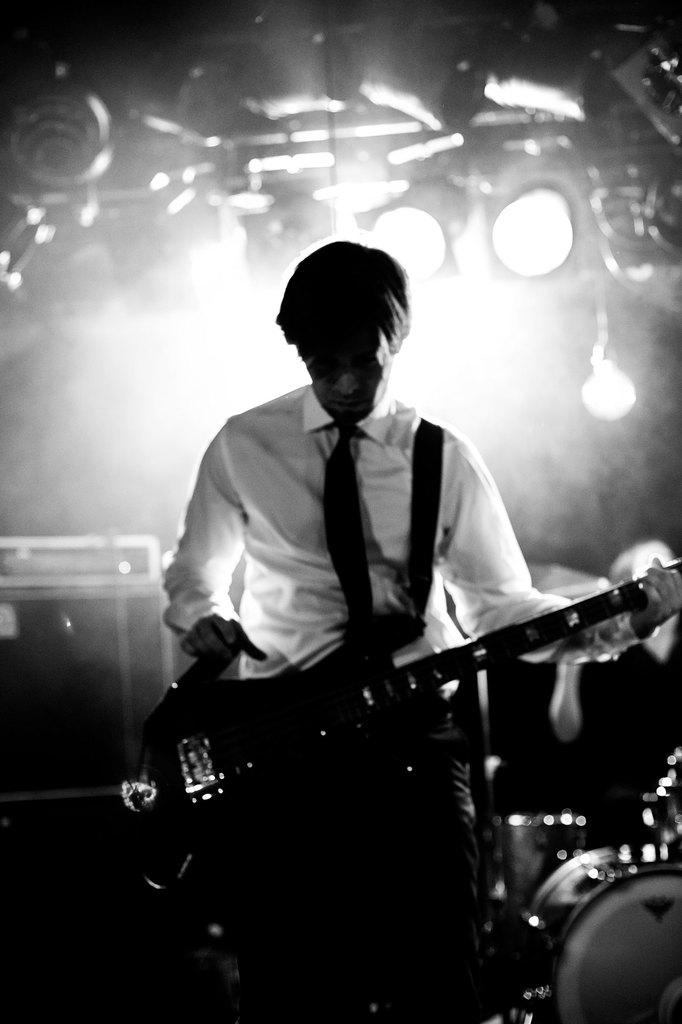What is the man in the image holding? The man is holding a guitar. What type of clothing is the man wearing around his neck? The man is wearing a tie. What color is the shirt the man is wearing? The man is wearing a white color shirt. What musical instrument can be seen in the background of the image? There are drums in the background of the image. What can be seen illuminating the background of the image? There are lights in the background of the image. What object can be seen in the background of the image, which is not related to music? There is a box in the background of the image. What type of silverware can be seen in the image? There is no silverware present in the image. 